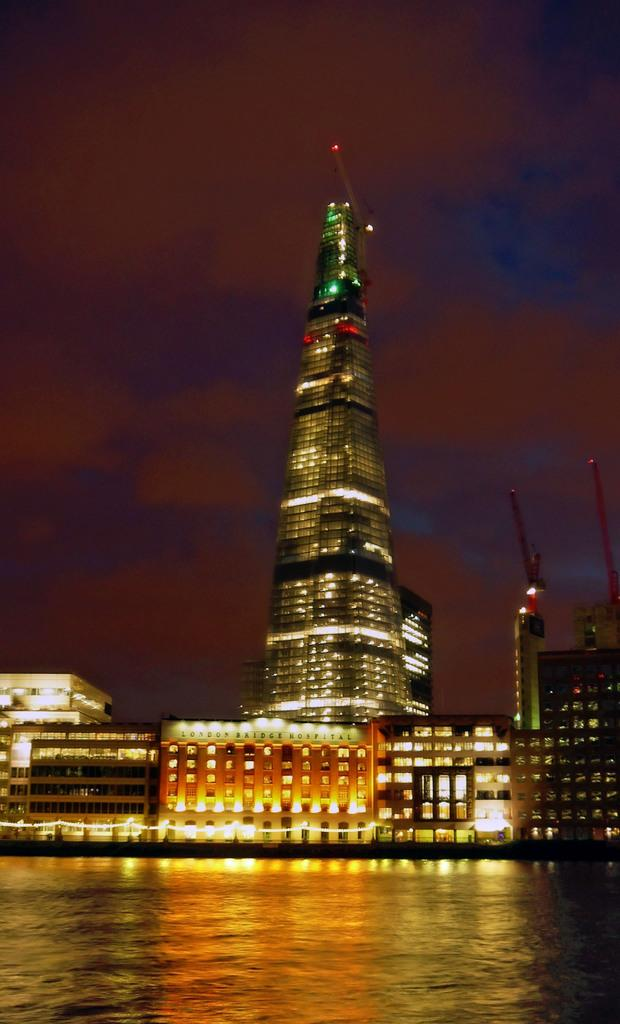What is visible in front of the image? There is water in front of the image. What can be seen in the distance in the image? There are buildings and cranes in the background of the image. What type of lighting is present in the background of the image? There are lights in the background of the image. What is visible in the sky at the top of the image? There are clouds in the sky at the top of the image. How many mice are running on the patch in the image? There are no mice or patches present in the image. What type of road can be seen in the image? There is no road visible in the image; it features water in front and buildings, cranes, and lights in the background. 